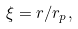<formula> <loc_0><loc_0><loc_500><loc_500>\xi = r / r _ { p } ,</formula> 